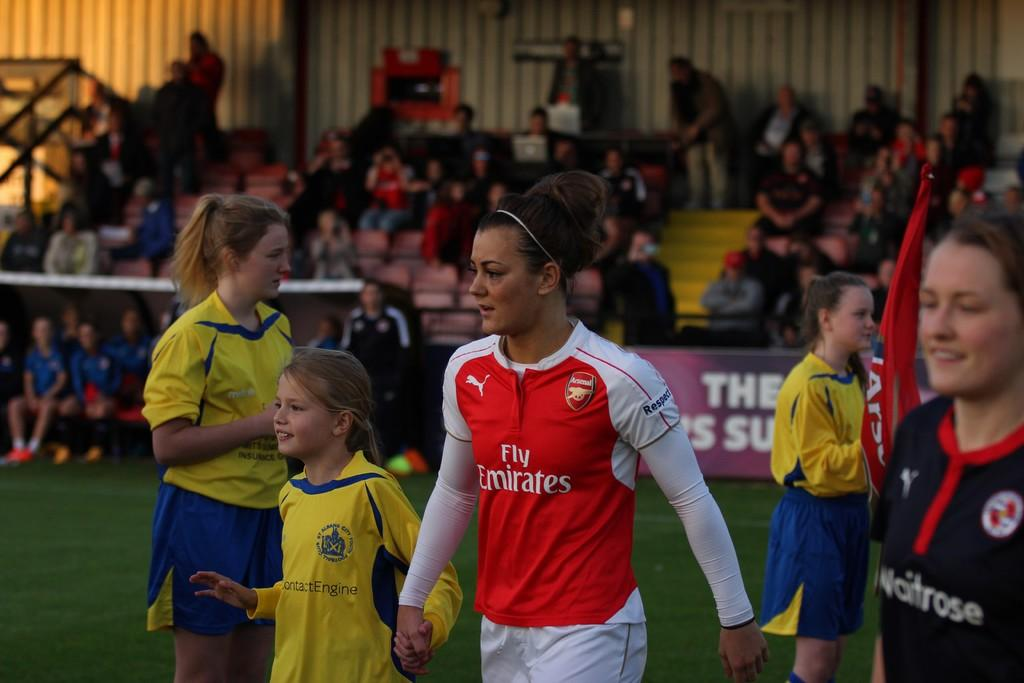How many people are in the image? There are people in the image, but the exact number is not specified. What is one person doing in the image? One person is holding a flag in the image. What type of terrain is visible in the image? There is grass visible in the image. What is the quality of the background in the image? The background of the image is blurry. Can you describe the people in the background of the image? There are people in the background of the image, but their specific actions or features are not mentioned. What type of signage is present in the background of the image? There is a hoarding in the background of the image. What type of juice is being served at the zoo in the image? There is no mention of a zoo or juice in the image, so it cannot be determined from the image. 